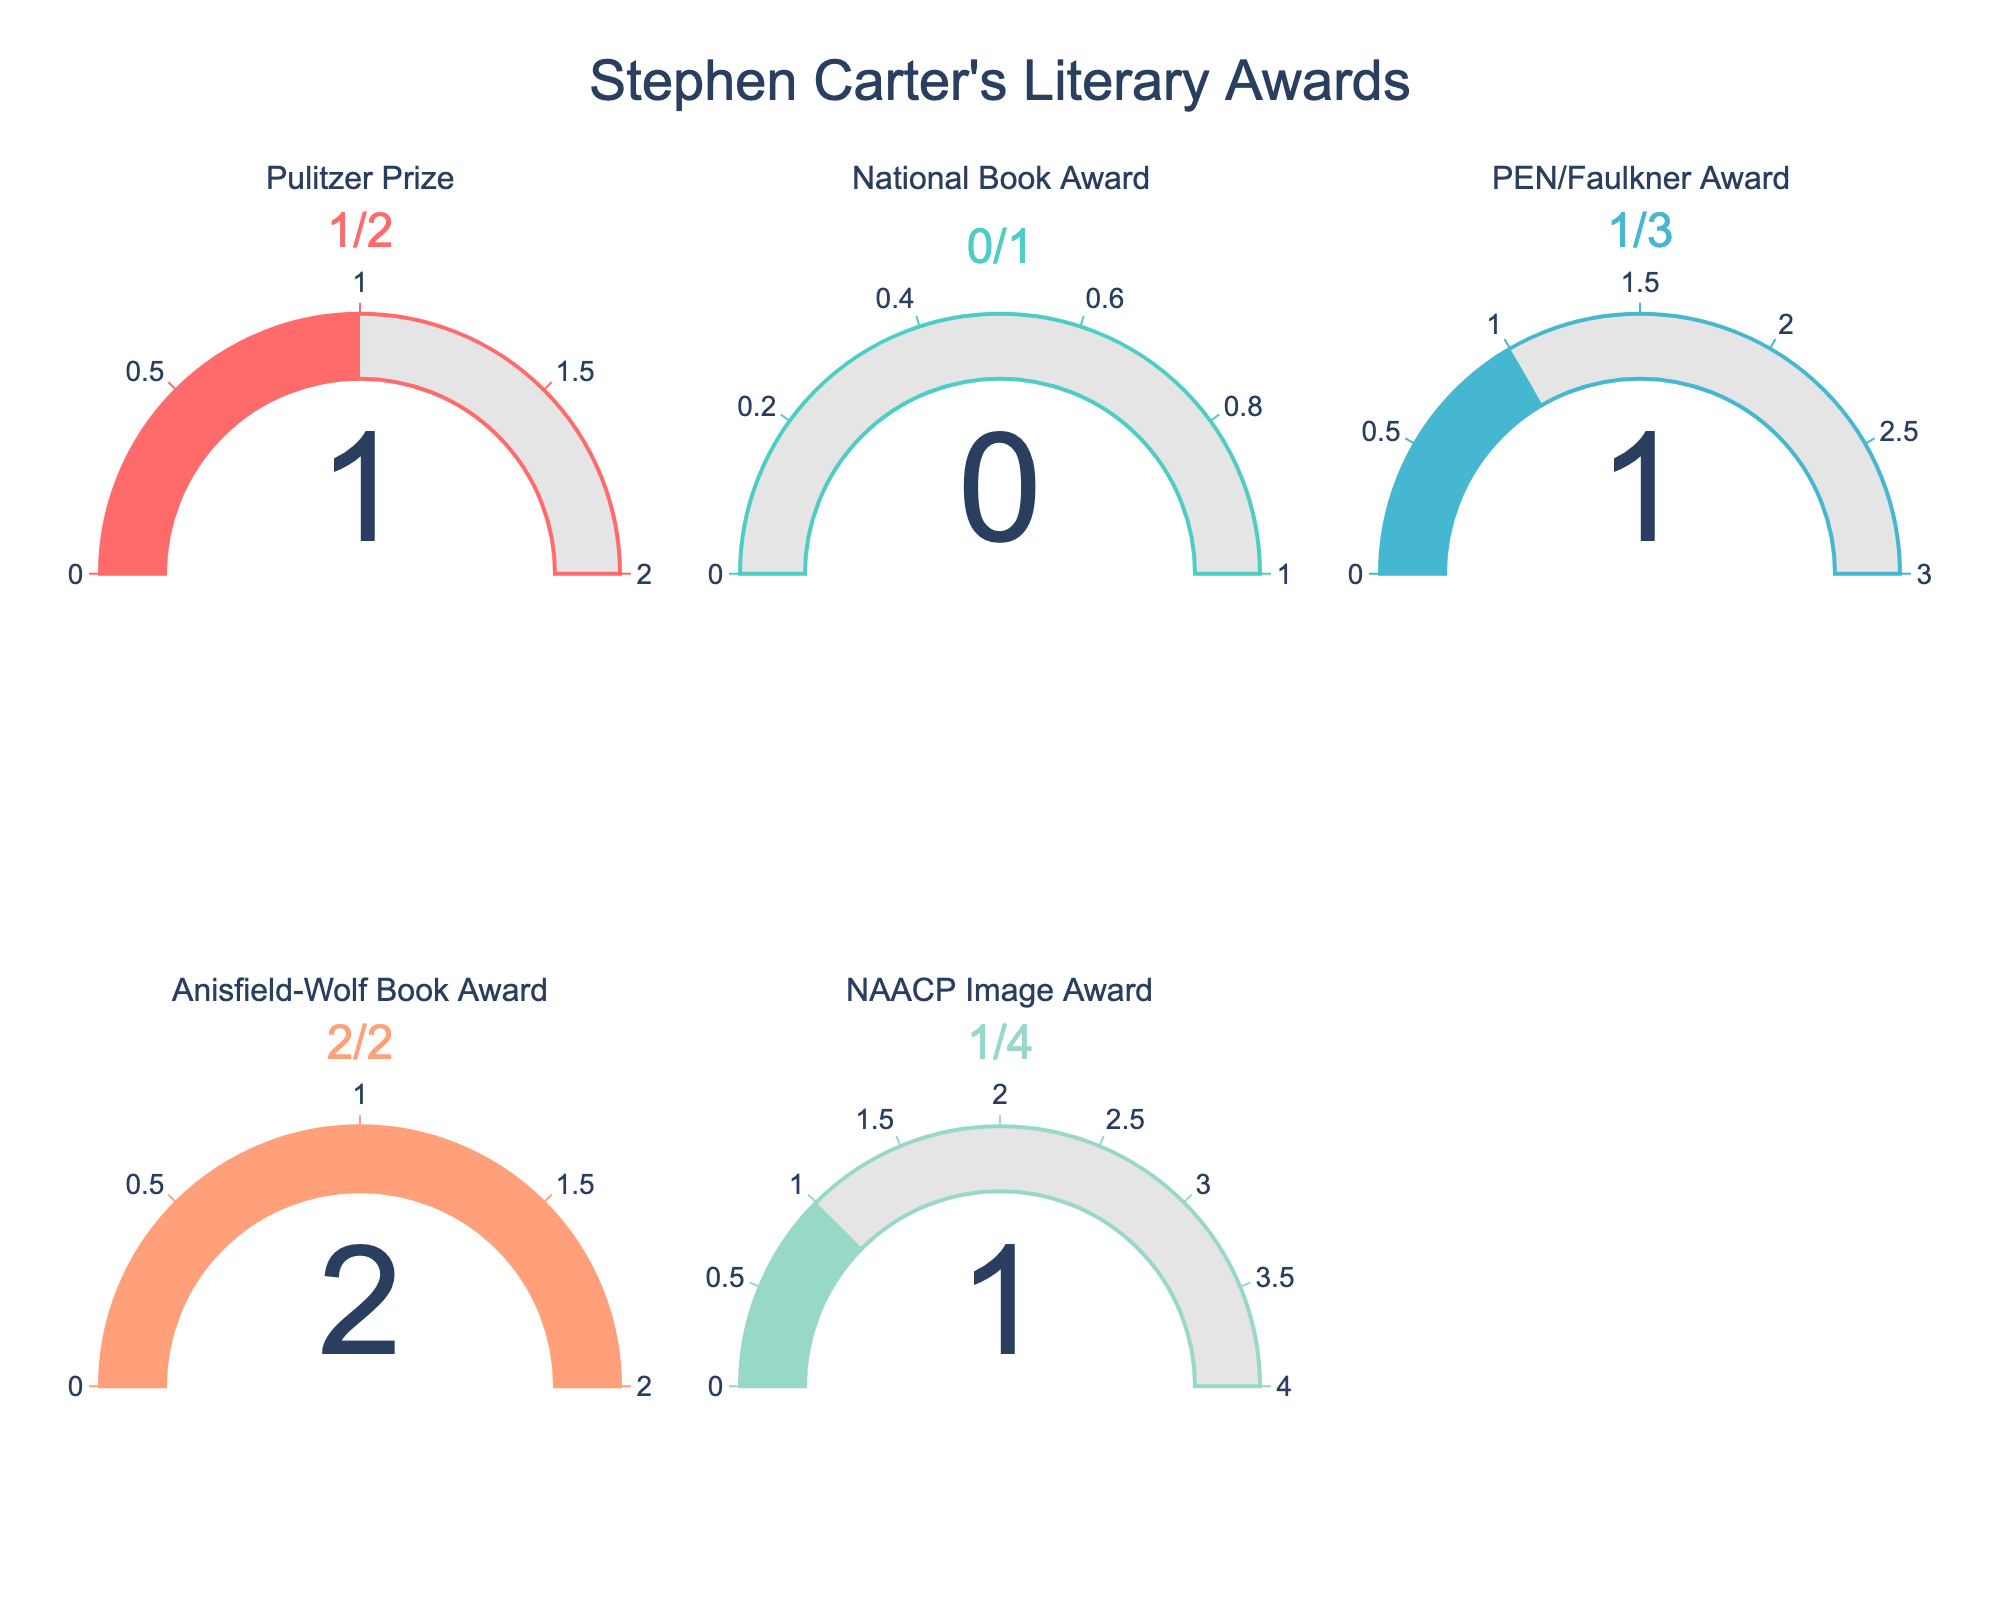What's the title of the figure? The title of the figure is prominently displayed at the top.
Answer: Stephen Carter's Literary Awards How many awards did Stephen Carter win without any nominations? By observing the gauges, the National Book Award gauge reads 0/1, indicating that he won this award without any nominations.
Answer: 0 Which award did Stephen Carter have a perfect nomination-to-win ratio? By checking the gauges and comparing the number of wins to nominations, the Anisfield-Wolf Book Award gauge shows 2/2, meaning he won both times he was nominated.
Answer: Anisfield-Wolf Book Award What's the total number of awards Stephen Carter was nominated for? Sum the total nominations across all gauge titles: 2 (Pulitzer Prize) + 1 (National Book Award) + 3 (PEN/Faulkner Award) + 2 (Anisfield-Wolf Book Award) + 4 (NAACP Image Award) = 12.
Answer: 12 On which award did Stephen Carter have the highest number of nominations without winning? Observing the gauges, the NAACP Image Award gauge reads 1/4, indicating that he did not win on three occasions.
Answer: NAACP Image Award How many awards did Stephen Carter win in total? Sum the total wins across all gauges: 1 (Pulitzer Prize) + 0 (National Book Award) + 1 (PEN/Faulkner Award) + 2 (Anisfield-Wolf Book Award) + 1 (NAACP Image Award) = 5.
Answer: 5 Which award did Stephen Carter have the lowest win ratio? Calculate the ratio for each award by dividing the number of wins by nominations and compare: Pulitzer Prize = 1/2 (0.5), National Book Award = 0/1 (0), PEN/Faulkner Award = 1/3 (0.33), Anisfield-Wolf Book Award = 2/2 (1), NAACP Image Award = 1/4 (0.25). The National Book Award has the lowest ratio.
Answer: National Book Award What is the range of the gauge for the PEN/Faulkner Award? The range of the gauge is indicated by the highest number on the gauge, which corresponds to the number of nominations. For the PEN/Faulkner Award, this is seen in the title as 3.
Answer: 3 Is the gauge chart better at highlighting the number of times Stephen Carter was nominated or the number of times he won? Gauges predominantly display the number of wins compared to nominations, thereby emphasizing the wins more clearly, with nominations serving as the context.
Answer: Emphasizes wins Which awards have Stephen Carter won exactly once? Observe the gauges and identify the titles with a win count of 1: Pulitzer Prize and NAACP Image Award.
Answer: Pulitzer Prize and NAACP Image Award 